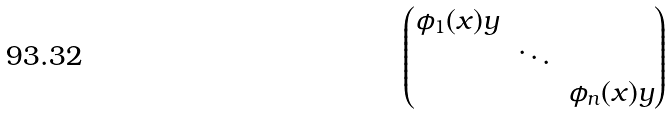<formula> <loc_0><loc_0><loc_500><loc_500>\begin{pmatrix} \phi _ { 1 } ( x ) y \\ & \ddots \\ & & \phi _ { n } ( x ) y \end{pmatrix}</formula> 